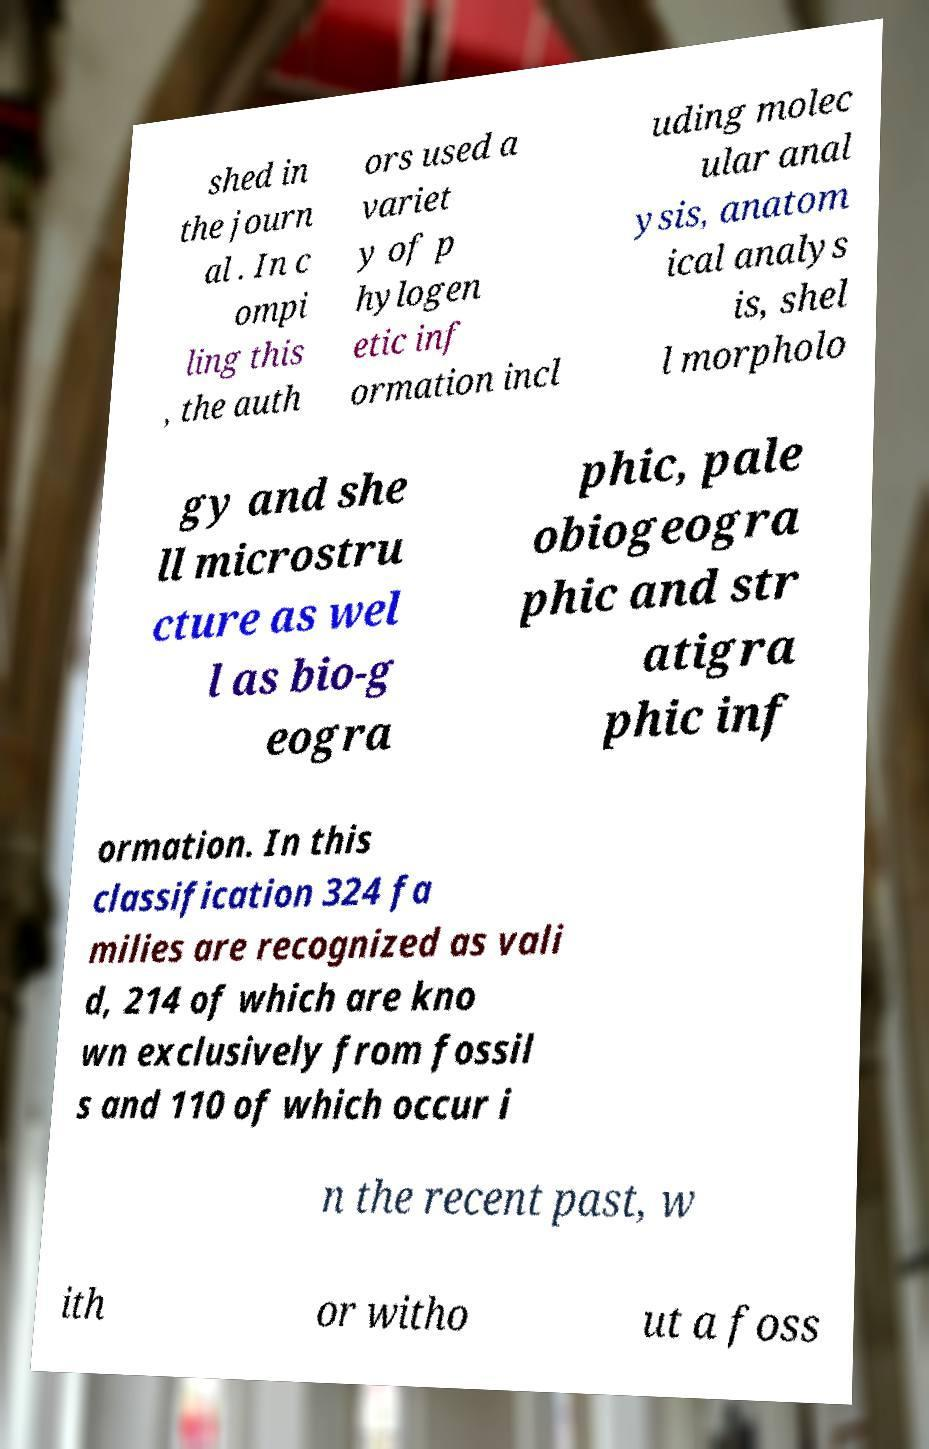Could you extract and type out the text from this image? shed in the journ al . In c ompi ling this , the auth ors used a variet y of p hylogen etic inf ormation incl uding molec ular anal ysis, anatom ical analys is, shel l morpholo gy and she ll microstru cture as wel l as bio-g eogra phic, pale obiogeogra phic and str atigra phic inf ormation. In this classification 324 fa milies are recognized as vali d, 214 of which are kno wn exclusively from fossil s and 110 of which occur i n the recent past, w ith or witho ut a foss 